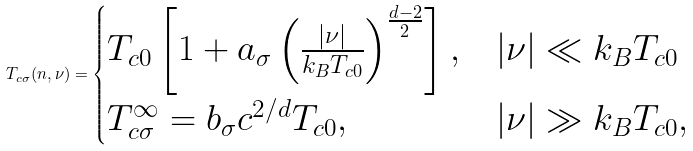Convert formula to latex. <formula><loc_0><loc_0><loc_500><loc_500>T _ { c \sigma } ( n , \nu ) = \begin{cases} T _ { c 0 } \left [ 1 + a _ { \sigma } \left ( \frac { | \nu | } { k _ { B } T _ { c 0 } } \right ) ^ { \frac { d - 2 } { 2 } } \right ] , & | \nu | \ll k _ { B } T _ { c 0 } \\ T _ { c \sigma } ^ { \infty } = b _ { \sigma } c ^ { 2 / d } T _ { c 0 } , & | \nu | \gg k _ { B } T _ { c 0 } , \end{cases}</formula> 